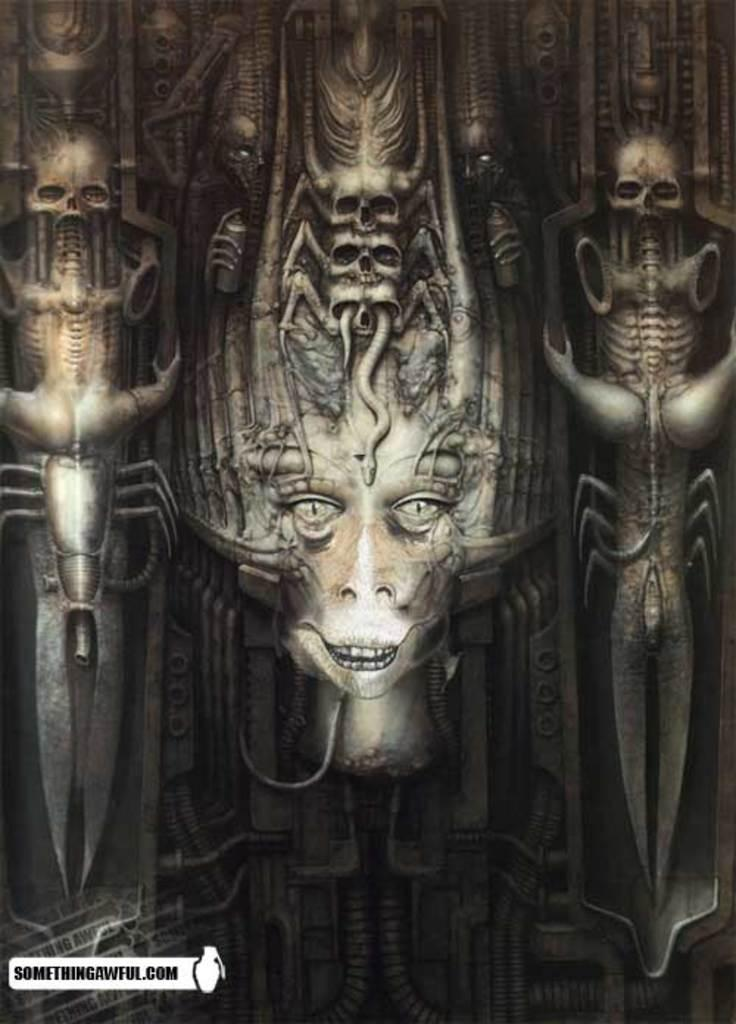What can be observed about the image's appearance? The image is edited. What type of art or objects are present in the image? There are sculptures in the image. What type of soda is being served in the image? There is no soda present in the image; it features sculptures. What is the limit of the sculptures in the image? The provided facts do not mention any limit or quantity of sculptures in the image. 